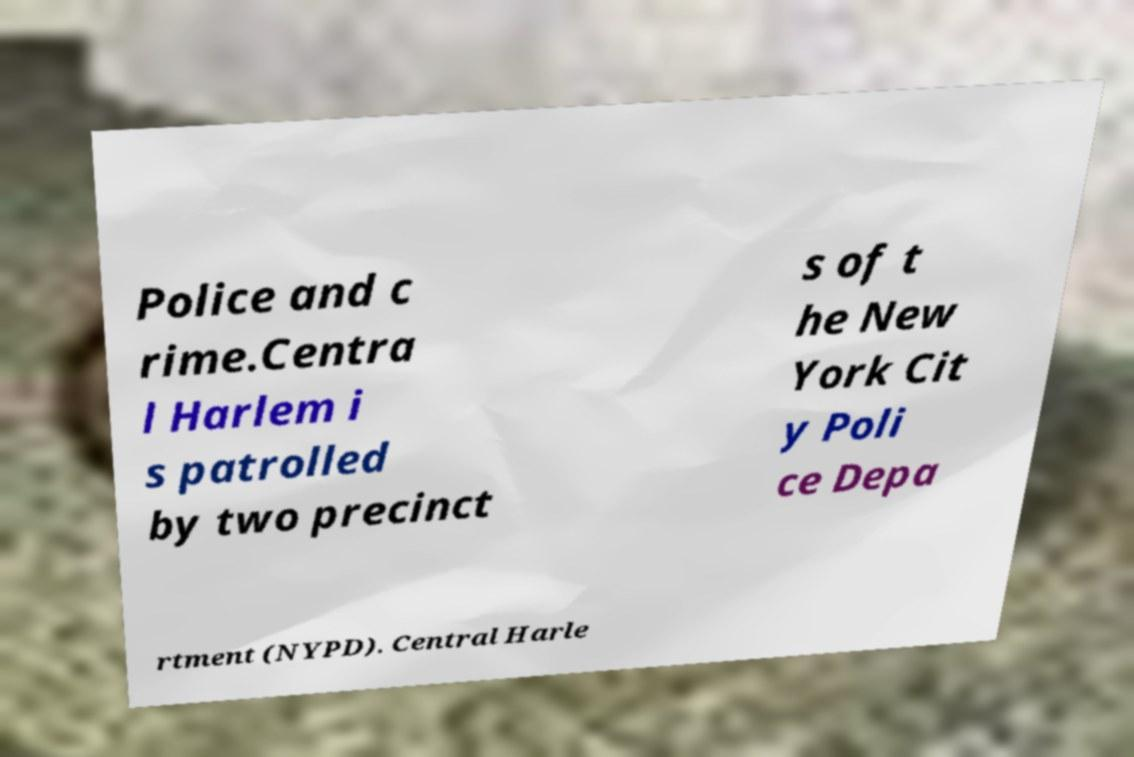What messages or text are displayed in this image? I need them in a readable, typed format. Police and c rime.Centra l Harlem i s patrolled by two precinct s of t he New York Cit y Poli ce Depa rtment (NYPD). Central Harle 